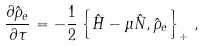Convert formula to latex. <formula><loc_0><loc_0><loc_500><loc_500>\frac { \partial \hat { \rho } _ { e } } { \partial \tau } = - \frac { 1 } { 2 } \left \{ \hat { H } - \mu \hat { N } , \hat { \rho } _ { e } \right \} _ { + } \, ,</formula> 